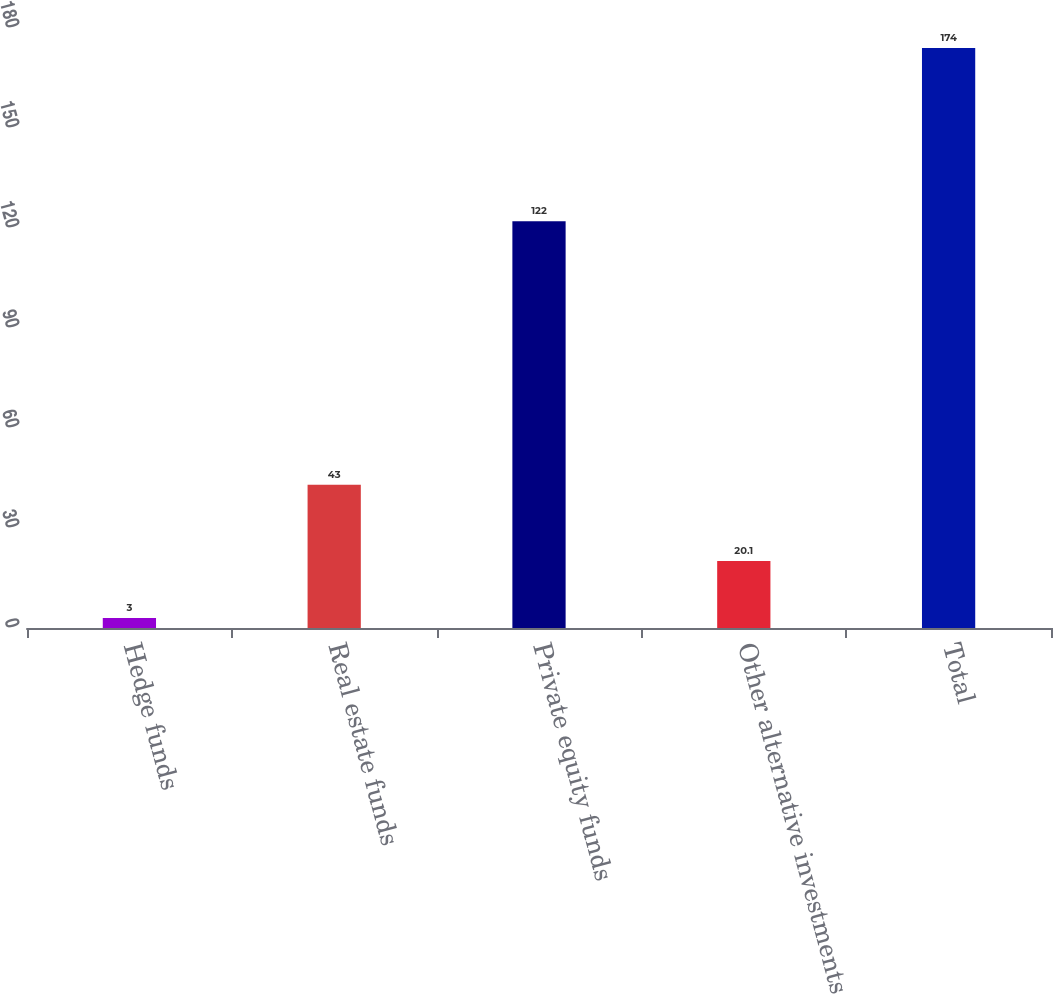Convert chart. <chart><loc_0><loc_0><loc_500><loc_500><bar_chart><fcel>Hedge funds<fcel>Real estate funds<fcel>Private equity funds<fcel>Other alternative investments<fcel>Total<nl><fcel>3<fcel>43<fcel>122<fcel>20.1<fcel>174<nl></chart> 